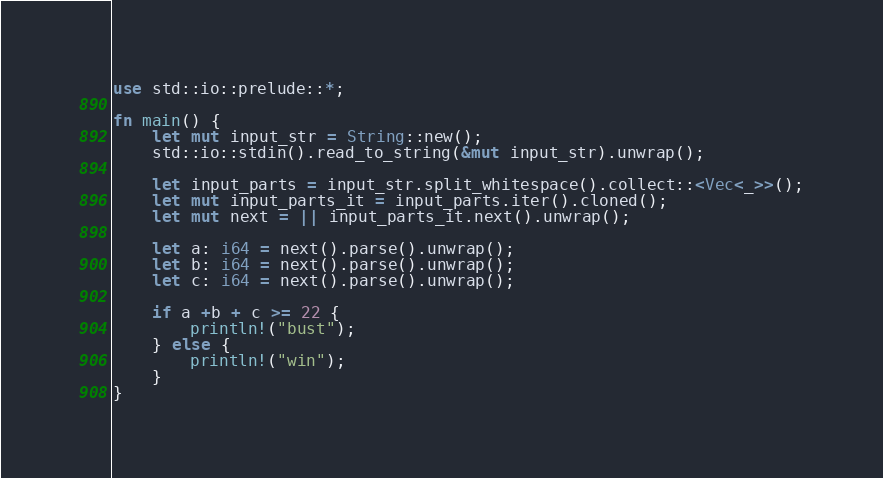Convert code to text. <code><loc_0><loc_0><loc_500><loc_500><_Rust_>use std::io::prelude::*;

fn main() {
    let mut input_str = String::new();
    std::io::stdin().read_to_string(&mut input_str).unwrap();

    let input_parts = input_str.split_whitespace().collect::<Vec<_>>();
    let mut input_parts_it = input_parts.iter().cloned();
    let mut next = || input_parts_it.next().unwrap();

    let a: i64 = next().parse().unwrap();
    let b: i64 = next().parse().unwrap();
    let c: i64 = next().parse().unwrap();

    if a +b + c >= 22 {
        println!("bust");
    } else {
        println!("win");
    }
}
</code> 